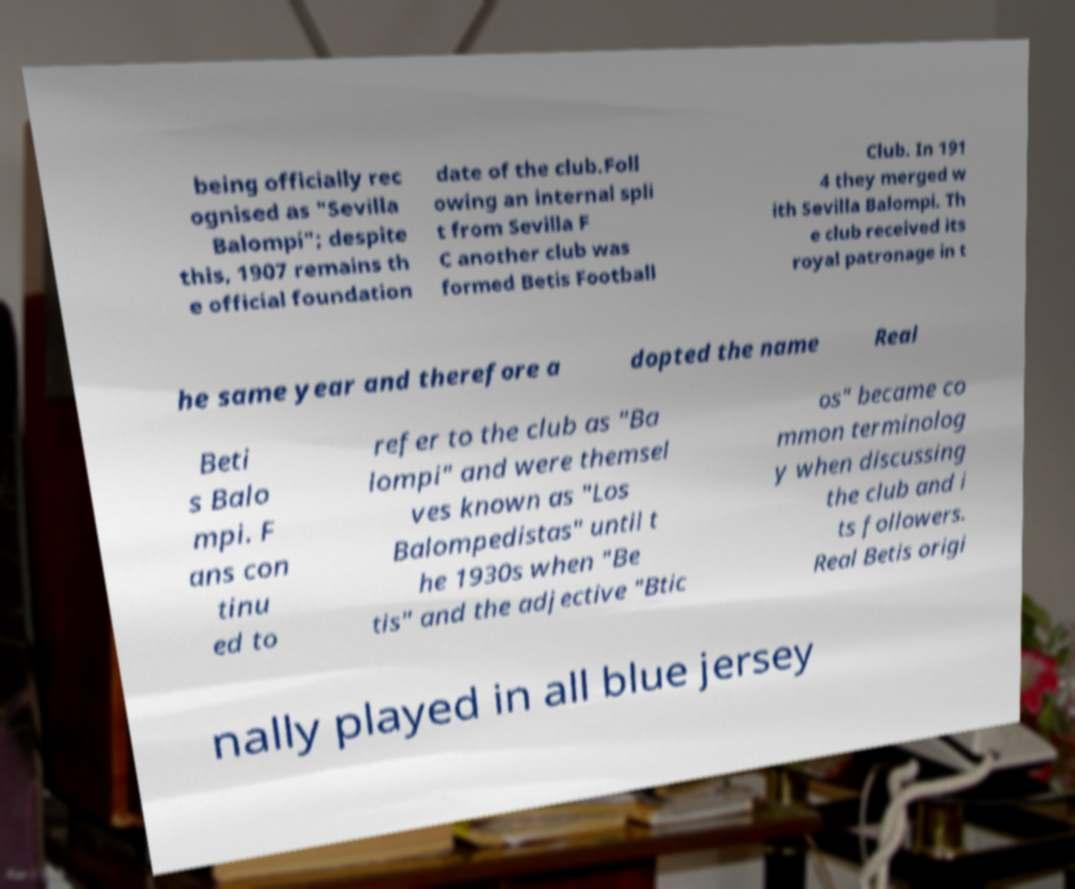For documentation purposes, I need the text within this image transcribed. Could you provide that? being officially rec ognised as "Sevilla Balompi"; despite this, 1907 remains th e official foundation date of the club.Foll owing an internal spli t from Sevilla F C another club was formed Betis Football Club. In 191 4 they merged w ith Sevilla Balompi. Th e club received its royal patronage in t he same year and therefore a dopted the name Real Beti s Balo mpi. F ans con tinu ed to refer to the club as "Ba lompi" and were themsel ves known as "Los Balompedistas" until t he 1930s when "Be tis" and the adjective "Btic os" became co mmon terminolog y when discussing the club and i ts followers. Real Betis origi nally played in all blue jersey 